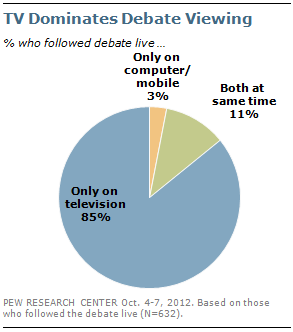Identify some key points in this picture. The sum of the two lowest values in the pie chart is 14. The color of the second lowest valve is green. 